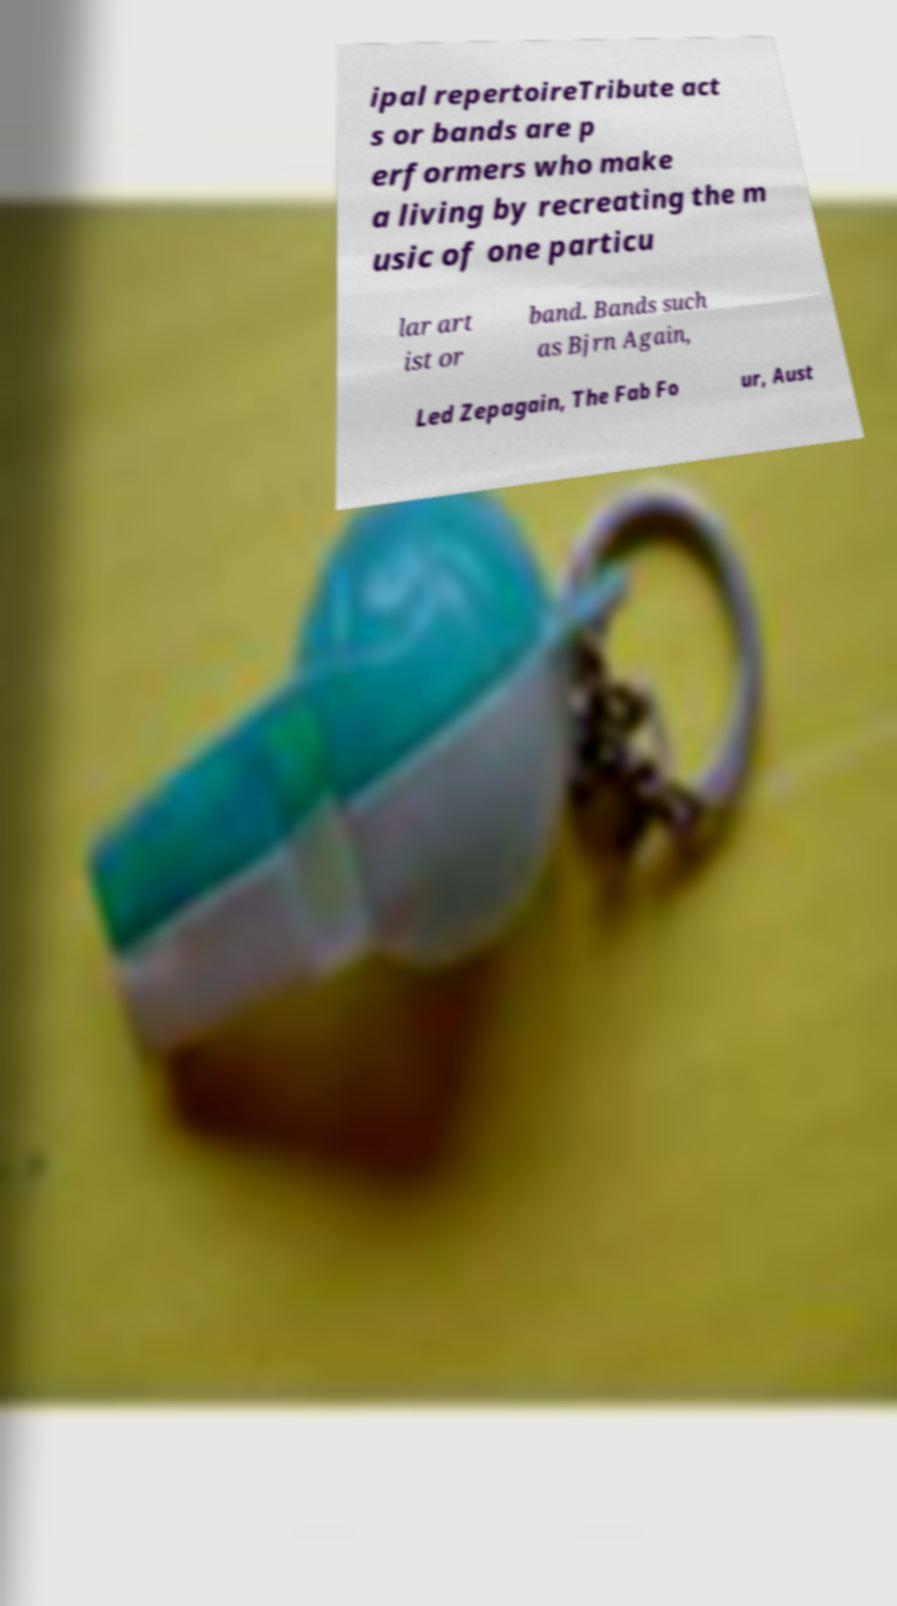What messages or text are displayed in this image? I need them in a readable, typed format. ipal repertoireTribute act s or bands are p erformers who make a living by recreating the m usic of one particu lar art ist or band. Bands such as Bjrn Again, Led Zepagain, The Fab Fo ur, Aust 